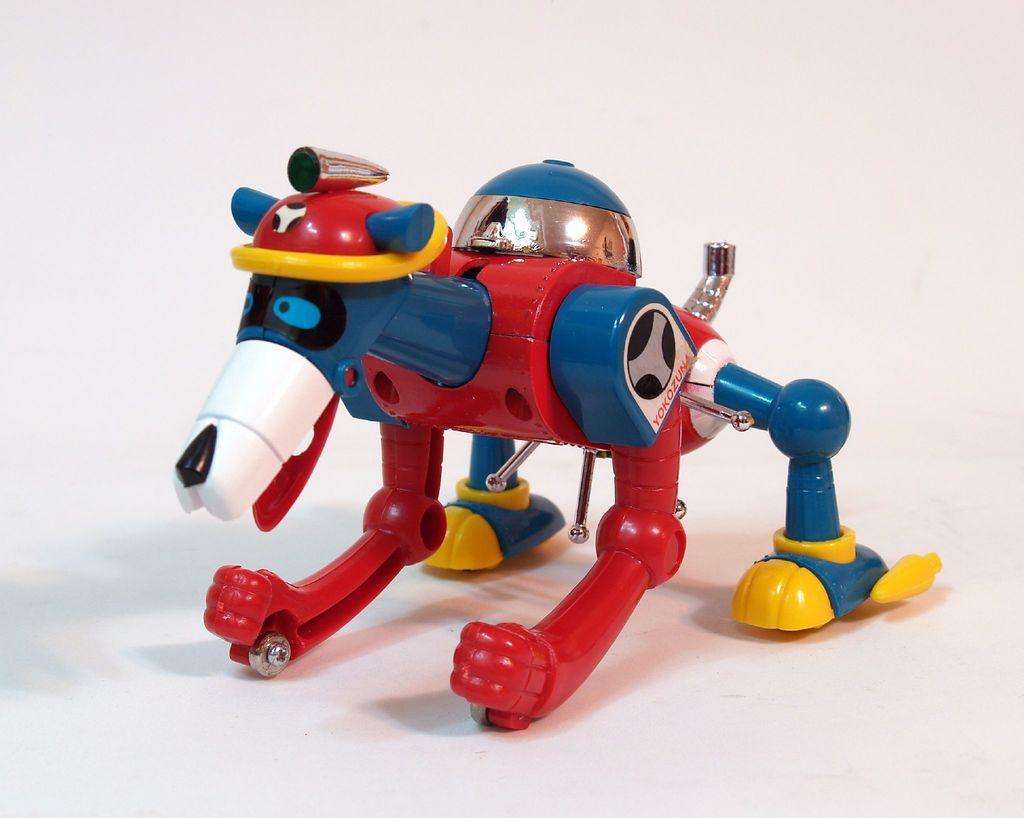Describe this image in one or two sentences. In this image we can see a toy on the white color surface. 